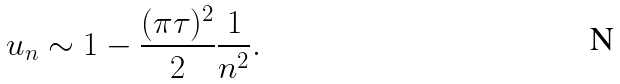<formula> <loc_0><loc_0><loc_500><loc_500>u _ { n } \sim 1 - \frac { ( \pi \tau ) ^ { 2 } } { 2 } \frac { 1 } { n ^ { 2 } } .</formula> 